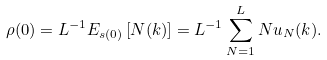Convert formula to latex. <formula><loc_0><loc_0><loc_500><loc_500>\rho ( 0 ) = L ^ { - 1 } E _ { s ( 0 ) } \left [ N ( k ) \right ] = L ^ { - 1 } \sum _ { N = 1 } ^ { L } N u _ { N } ( k ) .</formula> 